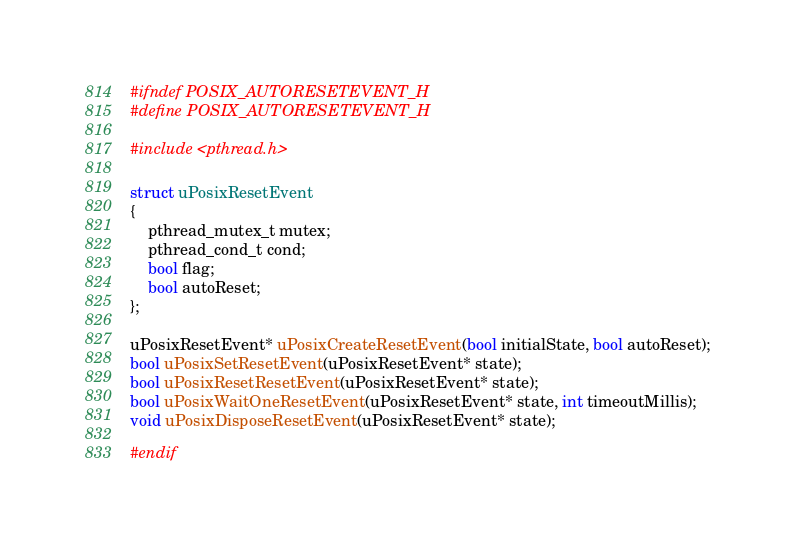<code> <loc_0><loc_0><loc_500><loc_500><_C_>#ifndef POSIX_AUTORESETEVENT_H
#define POSIX_AUTORESETEVENT_H

#include <pthread.h>

struct uPosixResetEvent
{
    pthread_mutex_t mutex;
    pthread_cond_t cond;
    bool flag;
    bool autoReset;
};

uPosixResetEvent* uPosixCreateResetEvent(bool initialState, bool autoReset);
bool uPosixSetResetEvent(uPosixResetEvent* state);
bool uPosixResetResetEvent(uPosixResetEvent* state);
bool uPosixWaitOneResetEvent(uPosixResetEvent* state, int timeoutMillis);
void uPosixDisposeResetEvent(uPosixResetEvent* state);

#endif
</code> 